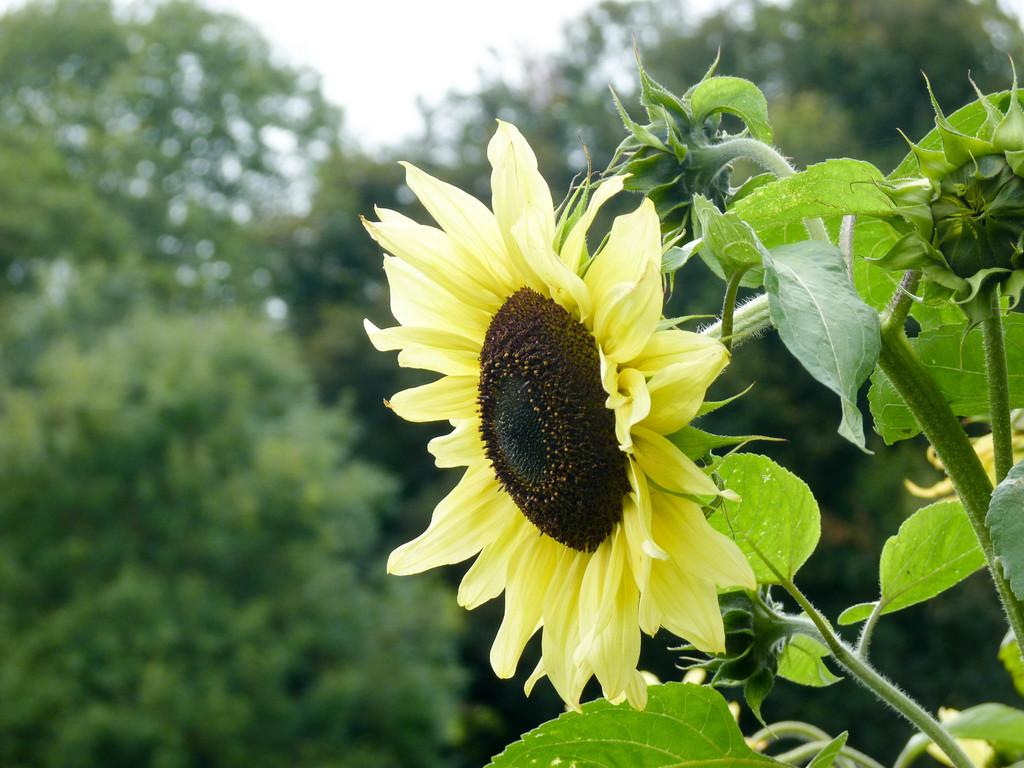What type of plant is in the picture? There is a sunflower in the picture. How is the background of the sunflower depicted in the image? The background of the sunflower is blurred. What type of yam can be seen growing on the mountain in the image? There is no yam or mountain present in the image; it features a sunflower with a blurred background. What scientific theory is being demonstrated by the sunflower in the image? The image does not depict a scientific theory; it simply shows a sunflower with a blurred background. 